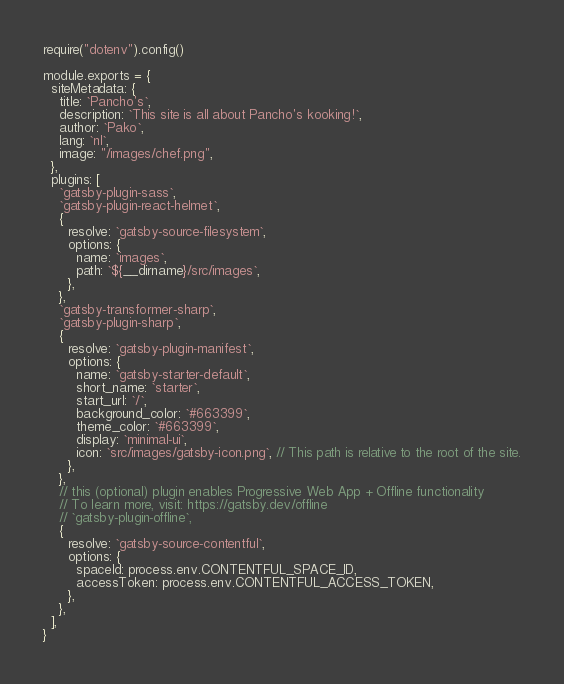<code> <loc_0><loc_0><loc_500><loc_500><_JavaScript_>require("dotenv").config()

module.exports = {
  siteMetadata: {
    title: `Pancho's`,
    description: `This site is all about Pancho's kooking!`,
    author: `Pako`,
    lang: `nl`,
    image: "/images/chef.png",
  },
  plugins: [
    `gatsby-plugin-sass`,
    `gatsby-plugin-react-helmet`,
    {
      resolve: `gatsby-source-filesystem`,
      options: {
        name: `images`,
        path: `${__dirname}/src/images`,
      },
    },
    `gatsby-transformer-sharp`,
    `gatsby-plugin-sharp`,
    {
      resolve: `gatsby-plugin-manifest`,
      options: {
        name: `gatsby-starter-default`,
        short_name: `starter`,
        start_url: `/`,
        background_color: `#663399`,
        theme_color: `#663399`,
        display: `minimal-ui`,
        icon: `src/images/gatsby-icon.png`, // This path is relative to the root of the site.
      },
    },
    // this (optional) plugin enables Progressive Web App + Offline functionality
    // To learn more, visit: https://gatsby.dev/offline
    // `gatsby-plugin-offline`,
    {
      resolve: `gatsby-source-contentful`,
      options: {
        spaceId: process.env.CONTENTFUL_SPACE_ID,
        accessToken: process.env.CONTENTFUL_ACCESS_TOKEN,
      },
    },
  ],
}
</code> 